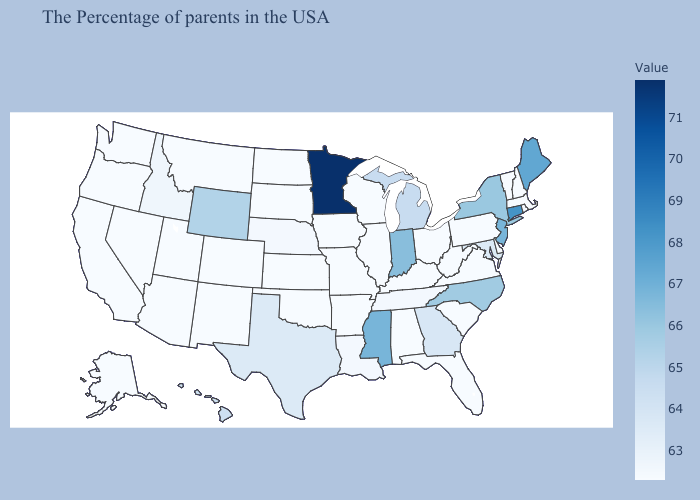Which states hav the highest value in the Northeast?
Be succinct. Connecticut. Among the states that border New Jersey , which have the highest value?
Keep it brief. New York. Which states have the lowest value in the South?
Quick response, please. Delaware, Virginia, South Carolina, West Virginia, Florida, Kentucky, Alabama, Arkansas, Oklahoma. Is the legend a continuous bar?
Be succinct. Yes. Does Alaska have the lowest value in the USA?
Quick response, please. Yes. Does the map have missing data?
Concise answer only. No. 